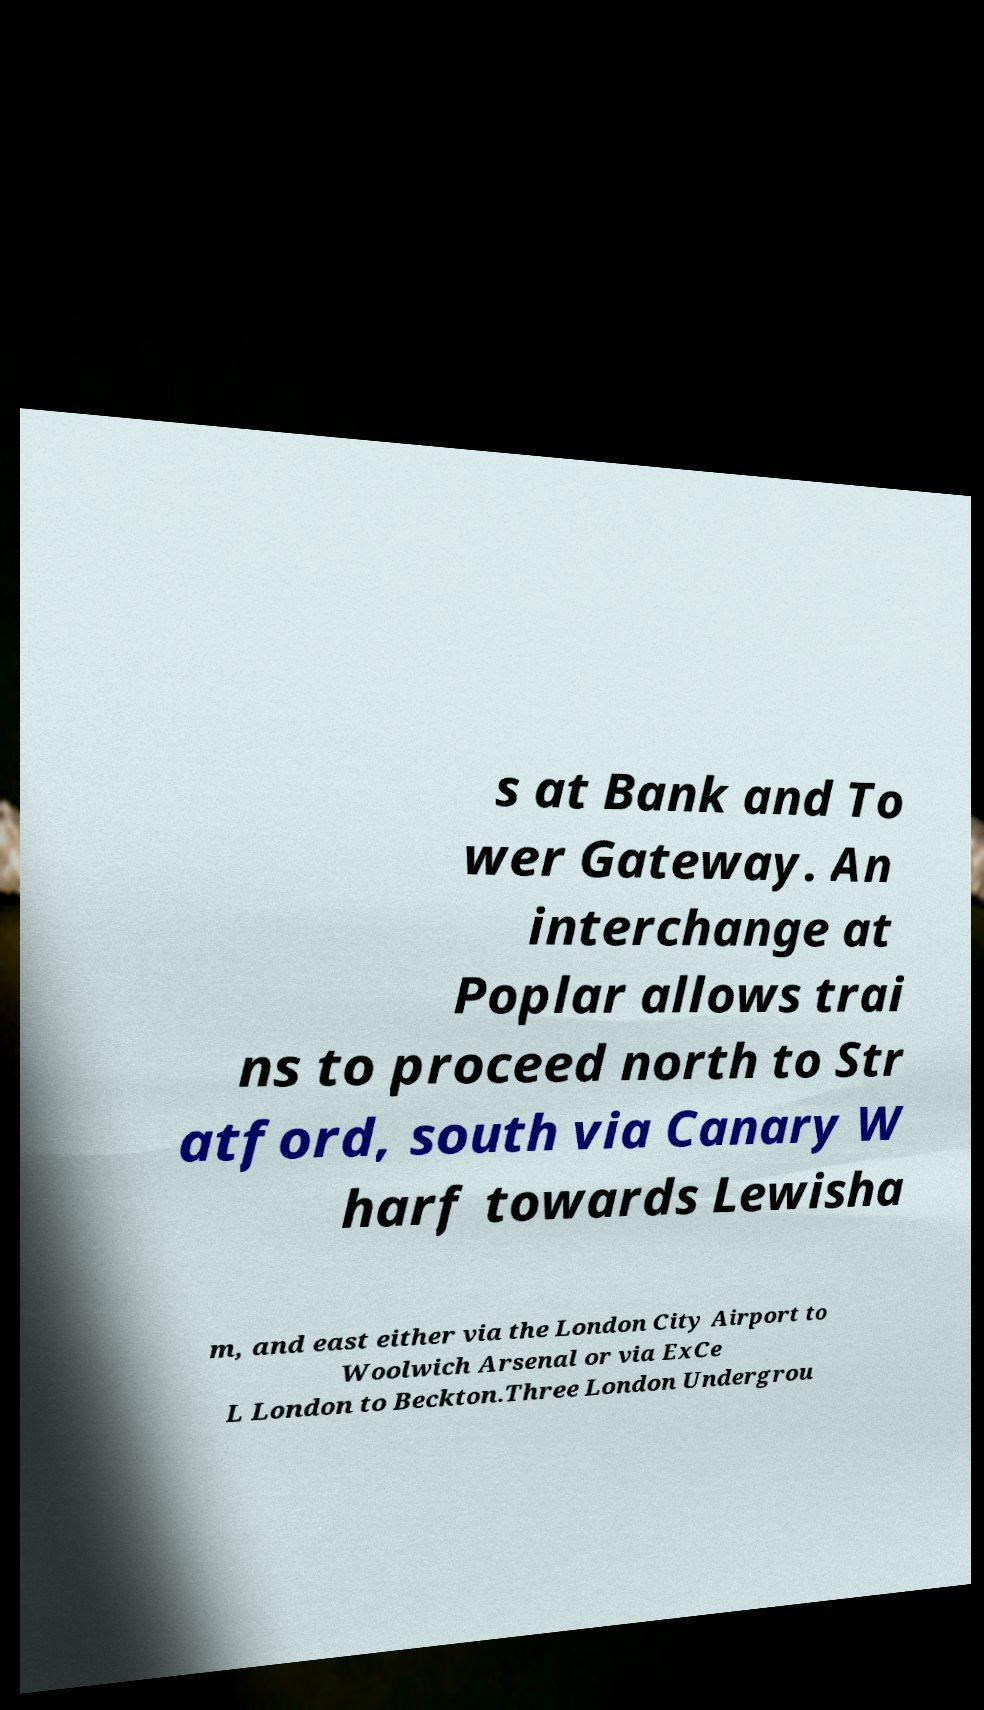Could you extract and type out the text from this image? s at Bank and To wer Gateway. An interchange at Poplar allows trai ns to proceed north to Str atford, south via Canary W harf towards Lewisha m, and east either via the London City Airport to Woolwich Arsenal or via ExCe L London to Beckton.Three London Undergrou 